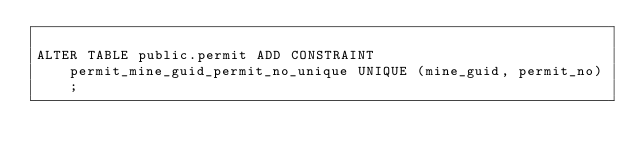Convert code to text. <code><loc_0><loc_0><loc_500><loc_500><_SQL_>
ALTER TABLE public.permit ADD CONSTRAINT permit_mine_guid_permit_no_unique UNIQUE (mine_guid, permit_no);</code> 